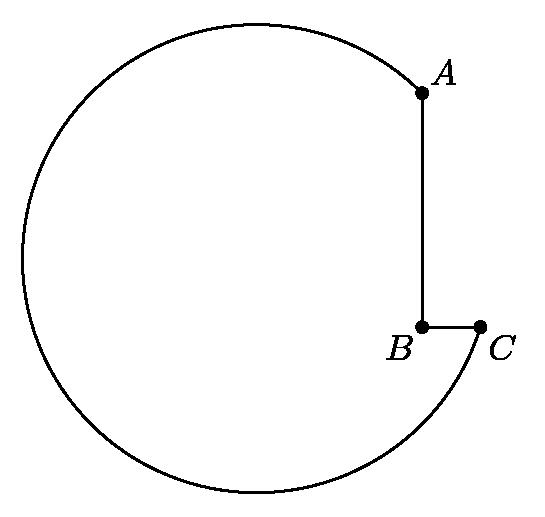A machine-shop cutting tool has the shape of a notched circle, as shown. The radius of the circle is $\sqrt{50}$ cm, the length of $AB$ is 6 cm, and that of $BC$ is 2 cm. The angle $ABC$ is a right angle. Find the square of the distance (in centimeters) from $B$ to the center of the circle. To find the square of the distance from point B to the center of the circle, we use the Pythagorean theorem. Given the radius of the circle is $\sqrt{50}$ cm and $AB = 6$ cm, we can conceive a right triangle where one leg is $AB$, and the hypotenuse is the radius. The length from the center to point B, opposite $AB$, is then calculated as $\sqrt{50}^2 - 6^2 = 50 - 36 = 14$ cm. Thus, the square of this distance is indeed 14 cm^2. 